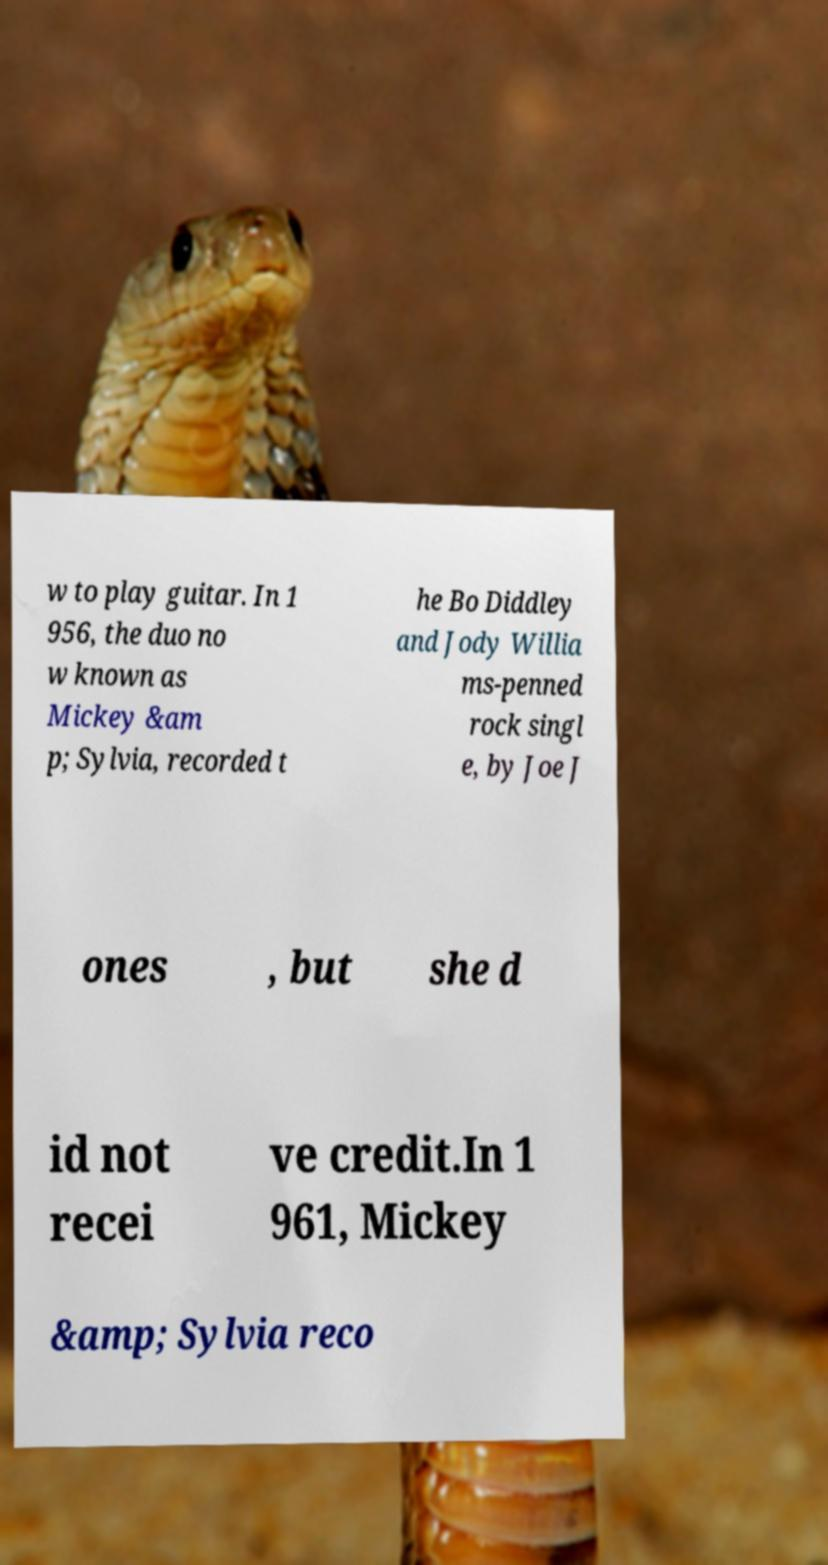Could you assist in decoding the text presented in this image and type it out clearly? w to play guitar. In 1 956, the duo no w known as Mickey &am p; Sylvia, recorded t he Bo Diddley and Jody Willia ms-penned rock singl e, by Joe J ones , but she d id not recei ve credit.In 1 961, Mickey &amp; Sylvia reco 